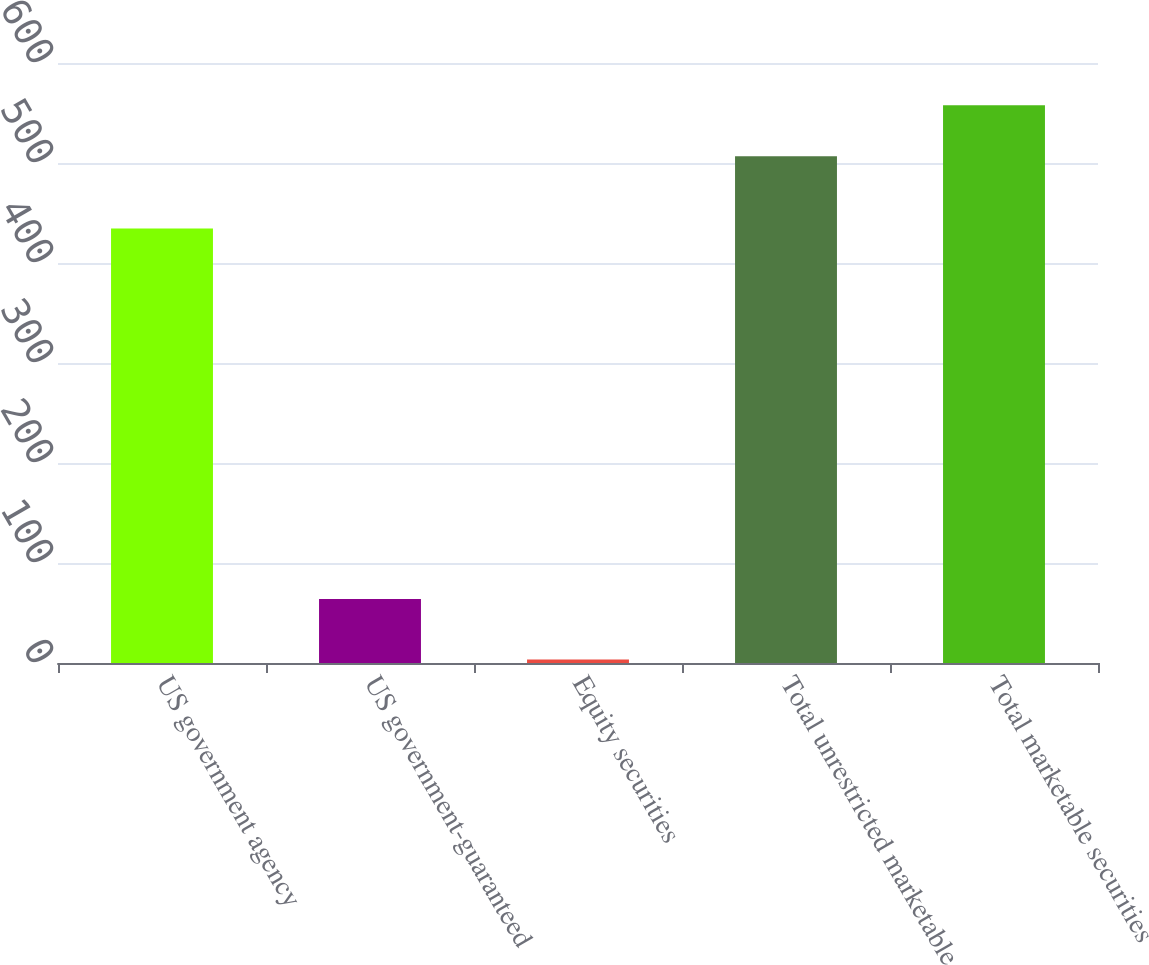<chart> <loc_0><loc_0><loc_500><loc_500><bar_chart><fcel>US government agency<fcel>US government-guaranteed<fcel>Equity securities<fcel>Total unrestricted marketable<fcel>Total marketable securities<nl><fcel>434.4<fcel>64<fcel>3.6<fcel>506.8<fcel>557.83<nl></chart> 